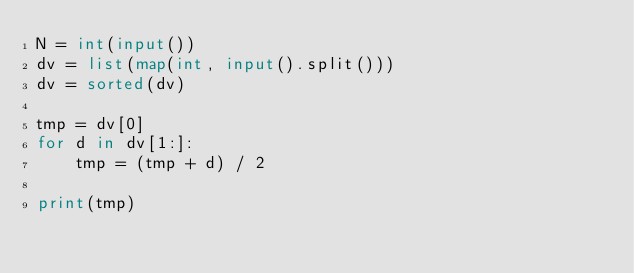Convert code to text. <code><loc_0><loc_0><loc_500><loc_500><_Python_>N = int(input())
dv = list(map(int, input().split()))
dv = sorted(dv)

tmp = dv[0]
for d in dv[1:]:
    tmp = (tmp + d) / 2

print(tmp)

</code> 